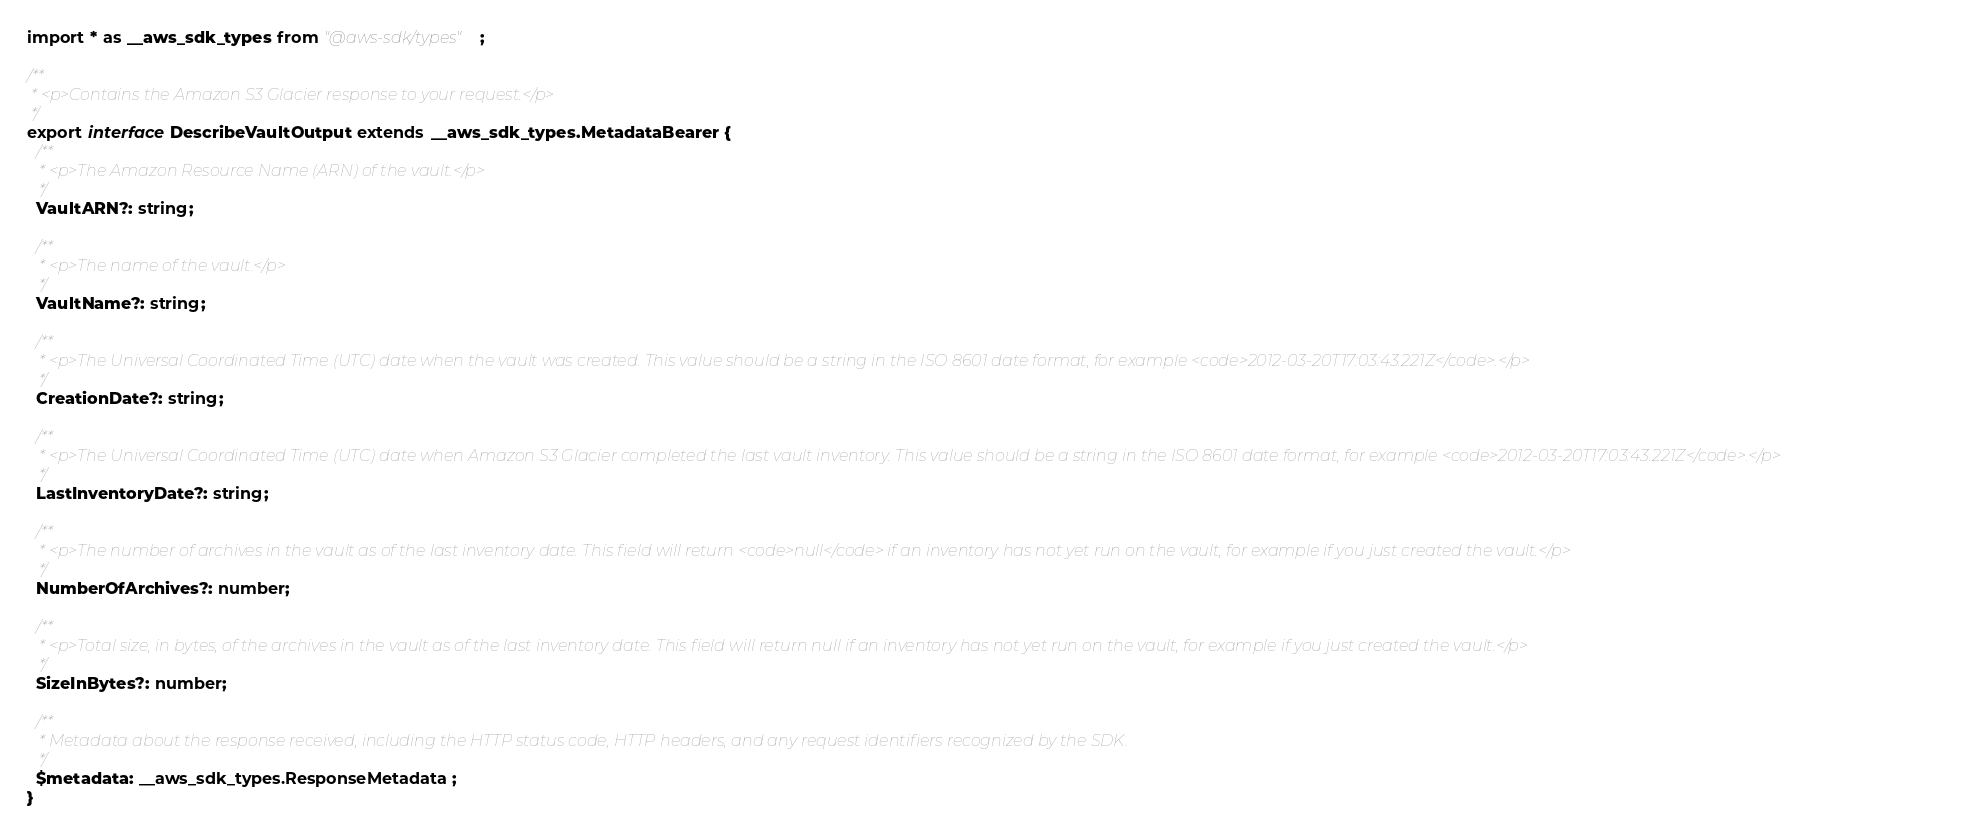Convert code to text. <code><loc_0><loc_0><loc_500><loc_500><_TypeScript_>import * as __aws_sdk_types from "@aws-sdk/types";

/**
 * <p>Contains the Amazon S3 Glacier response to your request.</p>
 */
export interface DescribeVaultOutput extends __aws_sdk_types.MetadataBearer {
  /**
   * <p>The Amazon Resource Name (ARN) of the vault.</p>
   */
  VaultARN?: string;

  /**
   * <p>The name of the vault.</p>
   */
  VaultName?: string;

  /**
   * <p>The Universal Coordinated Time (UTC) date when the vault was created. This value should be a string in the ISO 8601 date format, for example <code>2012-03-20T17:03:43.221Z</code>.</p>
   */
  CreationDate?: string;

  /**
   * <p>The Universal Coordinated Time (UTC) date when Amazon S3 Glacier completed the last vault inventory. This value should be a string in the ISO 8601 date format, for example <code>2012-03-20T17:03:43.221Z</code>.</p>
   */
  LastInventoryDate?: string;

  /**
   * <p>The number of archives in the vault as of the last inventory date. This field will return <code>null</code> if an inventory has not yet run on the vault, for example if you just created the vault.</p>
   */
  NumberOfArchives?: number;

  /**
   * <p>Total size, in bytes, of the archives in the vault as of the last inventory date. This field will return null if an inventory has not yet run on the vault, for example if you just created the vault.</p>
   */
  SizeInBytes?: number;

  /**
   * Metadata about the response received, including the HTTP status code, HTTP headers, and any request identifiers recognized by the SDK.
   */
  $metadata: __aws_sdk_types.ResponseMetadata;
}
</code> 